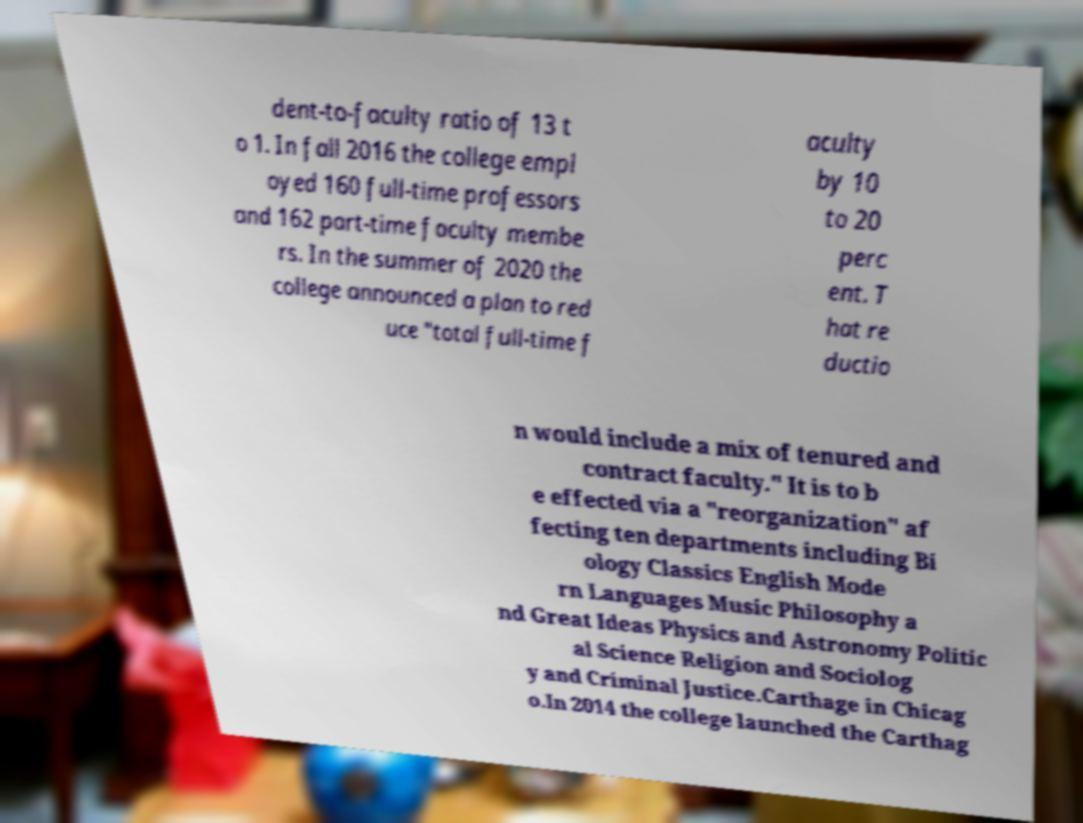Could you extract and type out the text from this image? dent-to-faculty ratio of 13 t o 1. In fall 2016 the college empl oyed 160 full-time professors and 162 part-time faculty membe rs. In the summer of 2020 the college announced a plan to red uce "total full-time f aculty by 10 to 20 perc ent. T hat re ductio n would include a mix of tenured and contract faculty." It is to b e effected via a "reorganization" af fecting ten departments including Bi ology Classics English Mode rn Languages Music Philosophy a nd Great Ideas Physics and Astronomy Politic al Science Religion and Sociolog y and Criminal Justice.Carthage in Chicag o.In 2014 the college launched the Carthag 